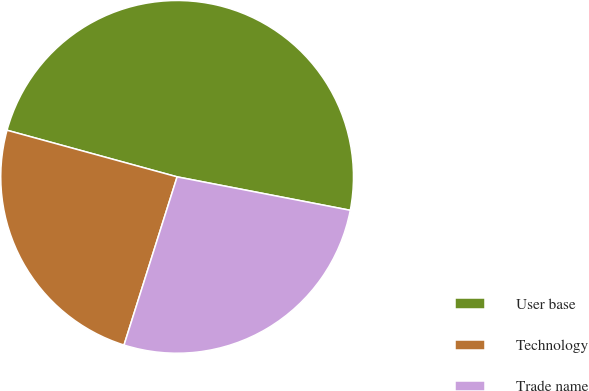Convert chart to OTSL. <chart><loc_0><loc_0><loc_500><loc_500><pie_chart><fcel>User base<fcel>Technology<fcel>Trade name<nl><fcel>48.78%<fcel>24.39%<fcel>26.83%<nl></chart> 